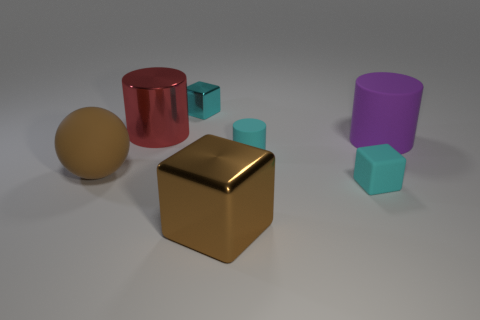Subtract all green cylinders. How many cyan blocks are left? 2 Subtract 1 cylinders. How many cylinders are left? 2 Add 1 cyan cubes. How many objects exist? 8 Subtract all cubes. How many objects are left? 4 Subtract 0 green cubes. How many objects are left? 7 Subtract all brown rubber balls. Subtract all tiny gray objects. How many objects are left? 6 Add 2 tiny cyan objects. How many tiny cyan objects are left? 5 Add 4 tiny matte blocks. How many tiny matte blocks exist? 5 